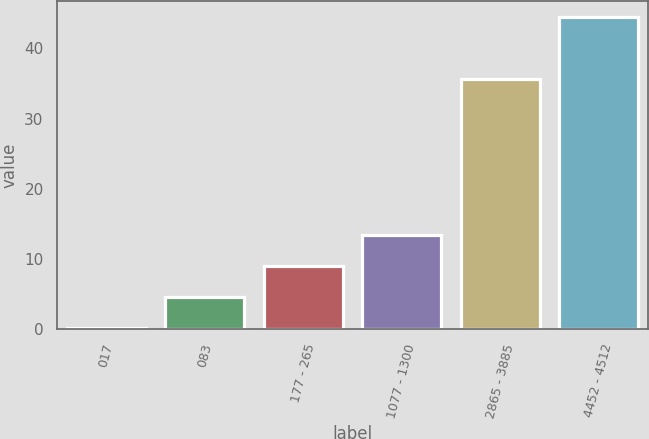<chart> <loc_0><loc_0><loc_500><loc_500><bar_chart><fcel>017<fcel>083<fcel>177 - 265<fcel>1077 - 1300<fcel>2865 - 3885<fcel>4452 - 4512<nl><fcel>0.17<fcel>4.61<fcel>9.05<fcel>13.49<fcel>35.69<fcel>44.52<nl></chart> 